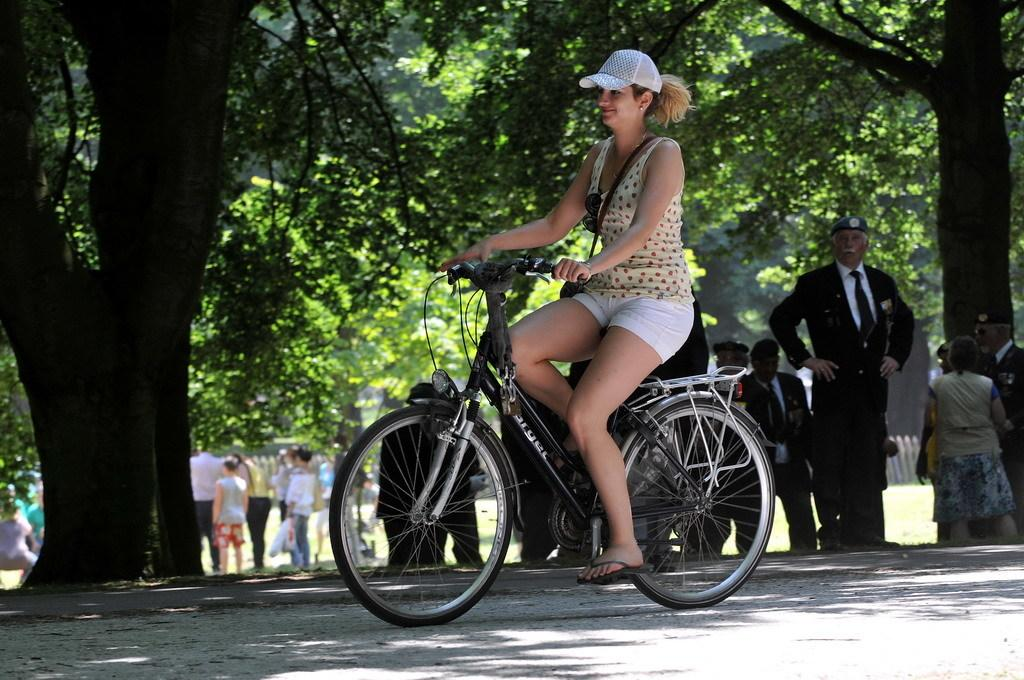What is the girl in the image doing? The girl is riding a bicycle. What is the girl wearing on her head? The girl is wearing a cap. What can be seen in the background of the image? There are trees, people standing far away, a fence, and grass in the distance. What type of bird can be seen singing on the fence in the image? There is no bird visible on the fence in the image. What kind of bell is attached to the girl's bicycle in the image? There is no bell mentioned or visible on the girl's bicycle in the image. 